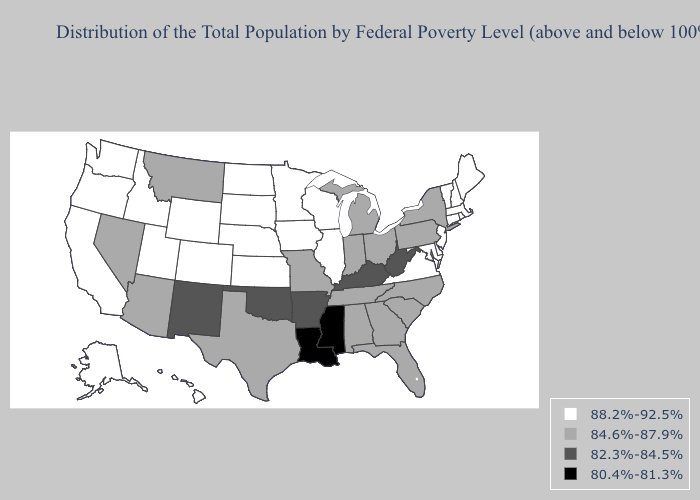Name the states that have a value in the range 88.2%-92.5%?
Be succinct. Alaska, California, Colorado, Connecticut, Delaware, Hawaii, Idaho, Illinois, Iowa, Kansas, Maine, Maryland, Massachusetts, Minnesota, Nebraska, New Hampshire, New Jersey, North Dakota, Oregon, Rhode Island, South Dakota, Utah, Vermont, Virginia, Washington, Wisconsin, Wyoming. Does Pennsylvania have the highest value in the Northeast?
Keep it brief. No. What is the value of Tennessee?
Keep it brief. 84.6%-87.9%. What is the value of Missouri?
Short answer required. 84.6%-87.9%. Does Louisiana have the lowest value in the South?
Quick response, please. Yes. Does Maryland have the highest value in the South?
Write a very short answer. Yes. Name the states that have a value in the range 82.3%-84.5%?
Answer briefly. Arkansas, Kentucky, New Mexico, Oklahoma, West Virginia. Which states have the lowest value in the USA?
Answer briefly. Louisiana, Mississippi. Name the states that have a value in the range 80.4%-81.3%?
Concise answer only. Louisiana, Mississippi. Which states have the lowest value in the USA?
Keep it brief. Louisiana, Mississippi. What is the lowest value in the South?
Quick response, please. 80.4%-81.3%. Which states have the lowest value in the USA?
Answer briefly. Louisiana, Mississippi. What is the value of Illinois?
Short answer required. 88.2%-92.5%. What is the highest value in the Northeast ?
Concise answer only. 88.2%-92.5%. Does New York have the highest value in the Northeast?
Be succinct. No. 